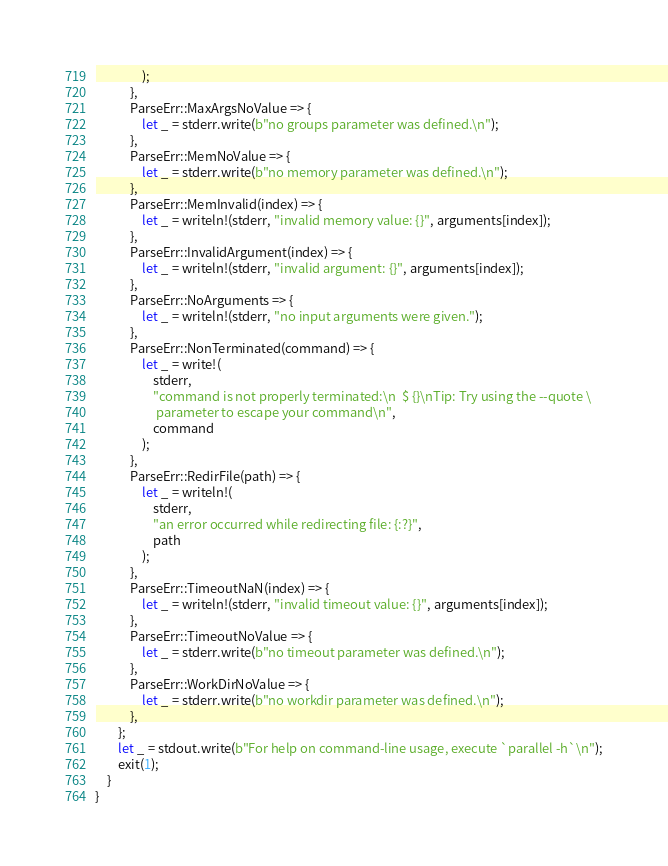<code> <loc_0><loc_0><loc_500><loc_500><_Rust_>                );
            },
            ParseErr::MaxArgsNoValue => {
                let _ = stderr.write(b"no groups parameter was defined.\n");
            },
            ParseErr::MemNoValue => {
                let _ = stderr.write(b"no memory parameter was defined.\n");
            },
            ParseErr::MemInvalid(index) => {
                let _ = writeln!(stderr, "invalid memory value: {}", arguments[index]);
            },
            ParseErr::InvalidArgument(index) => {
                let _ = writeln!(stderr, "invalid argument: {}", arguments[index]);
            },
            ParseErr::NoArguments => {
                let _ = writeln!(stderr, "no input arguments were given.");
            },
            ParseErr::NonTerminated(command) => {
                let _ = write!(
                    stderr,
                    "command is not properly terminated:\n  $ {}\nTip: Try using the --quote \
                     parameter to escape your command\n",
                    command
                );
            },
            ParseErr::RedirFile(path) => {
                let _ = writeln!(
                    stderr,
                    "an error occurred while redirecting file: {:?}",
                    path
                );
            },
            ParseErr::TimeoutNaN(index) => {
                let _ = writeln!(stderr, "invalid timeout value: {}", arguments[index]);
            },
            ParseErr::TimeoutNoValue => {
                let _ = stderr.write(b"no timeout parameter was defined.\n");
            },
            ParseErr::WorkDirNoValue => {
                let _ = stderr.write(b"no workdir parameter was defined.\n");
            },
        };
        let _ = stdout.write(b"For help on command-line usage, execute `parallel -h`\n");
        exit(1);
    }
}
</code> 